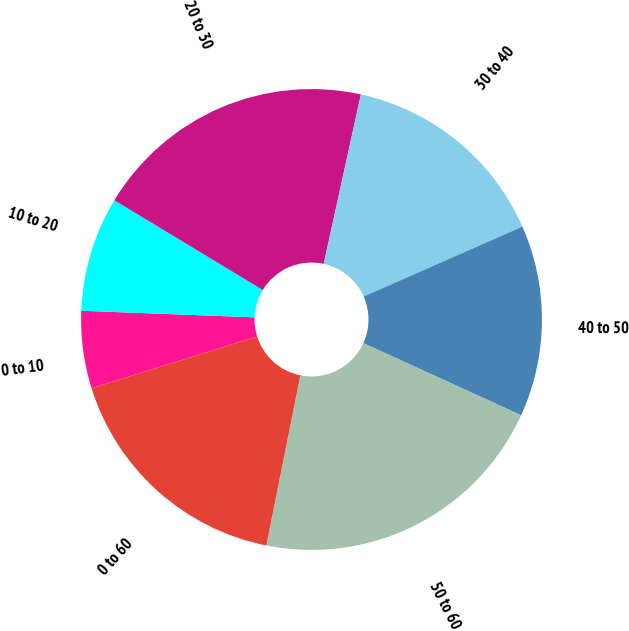Convert chart to OTSL. <chart><loc_0><loc_0><loc_500><loc_500><pie_chart><fcel>0 to 10<fcel>10 to 20<fcel>20 to 30<fcel>30 to 40<fcel>40 to 50<fcel>50 to 60<fcel>0 to 60<nl><fcel>5.43%<fcel>8.05%<fcel>19.78%<fcel>14.96%<fcel>13.42%<fcel>21.32%<fcel>17.03%<nl></chart> 